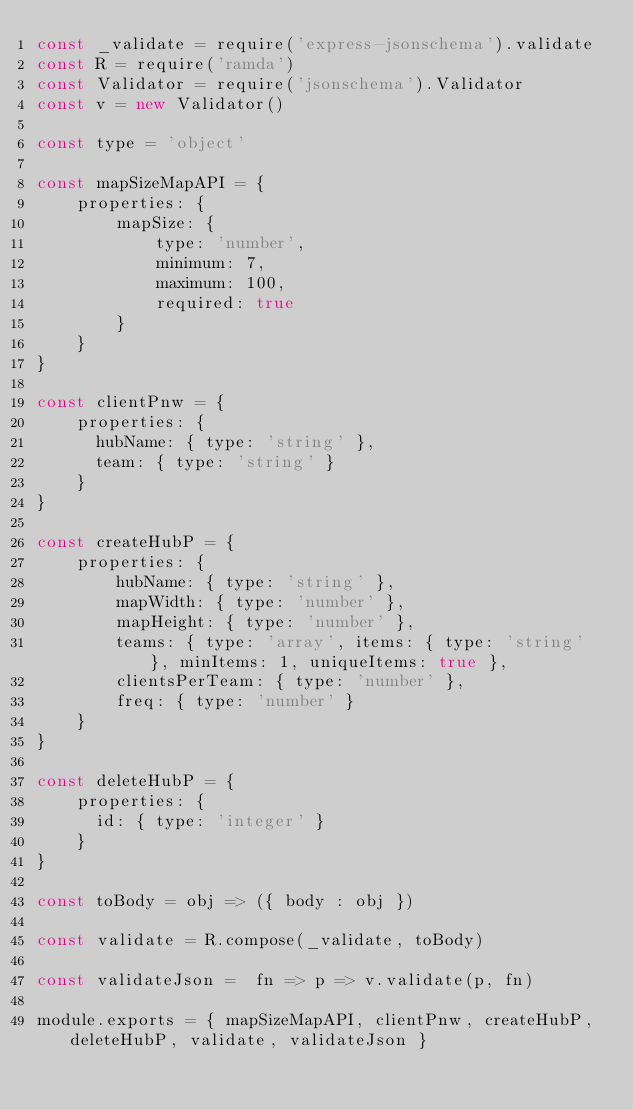Convert code to text. <code><loc_0><loc_0><loc_500><loc_500><_JavaScript_>const _validate = require('express-jsonschema').validate
const R = require('ramda')
const Validator = require('jsonschema').Validator
const v = new Validator()

const type = 'object'

const mapSizeMapAPI = {
    properties: {
        mapSize: {
            type: 'number',
            minimum: 7,
            maximum: 100,
            required: true
        }
    }
}

const clientPnw = {
    properties: {
      hubName: { type: 'string' },
      team: { type: 'string' }
    }
}

const createHubP = {
    properties: {
        hubName: { type: 'string' },
        mapWidth: { type: 'number' },
        mapHeight: { type: 'number' },
        teams: { type: 'array', items: { type: 'string' }, minItems: 1, uniqueItems: true },
        clientsPerTeam: { type: 'number' },
        freq: { type: 'number' }
    }
}

const deleteHubP = {
    properties: {
      id: { type: 'integer' }
    }
}

const toBody = obj => ({ body : obj })

const validate = R.compose(_validate, toBody)

const validateJson =  fn => p => v.validate(p, fn)

module.exports = { mapSizeMapAPI, clientPnw, createHubP, deleteHubP, validate, validateJson }</code> 